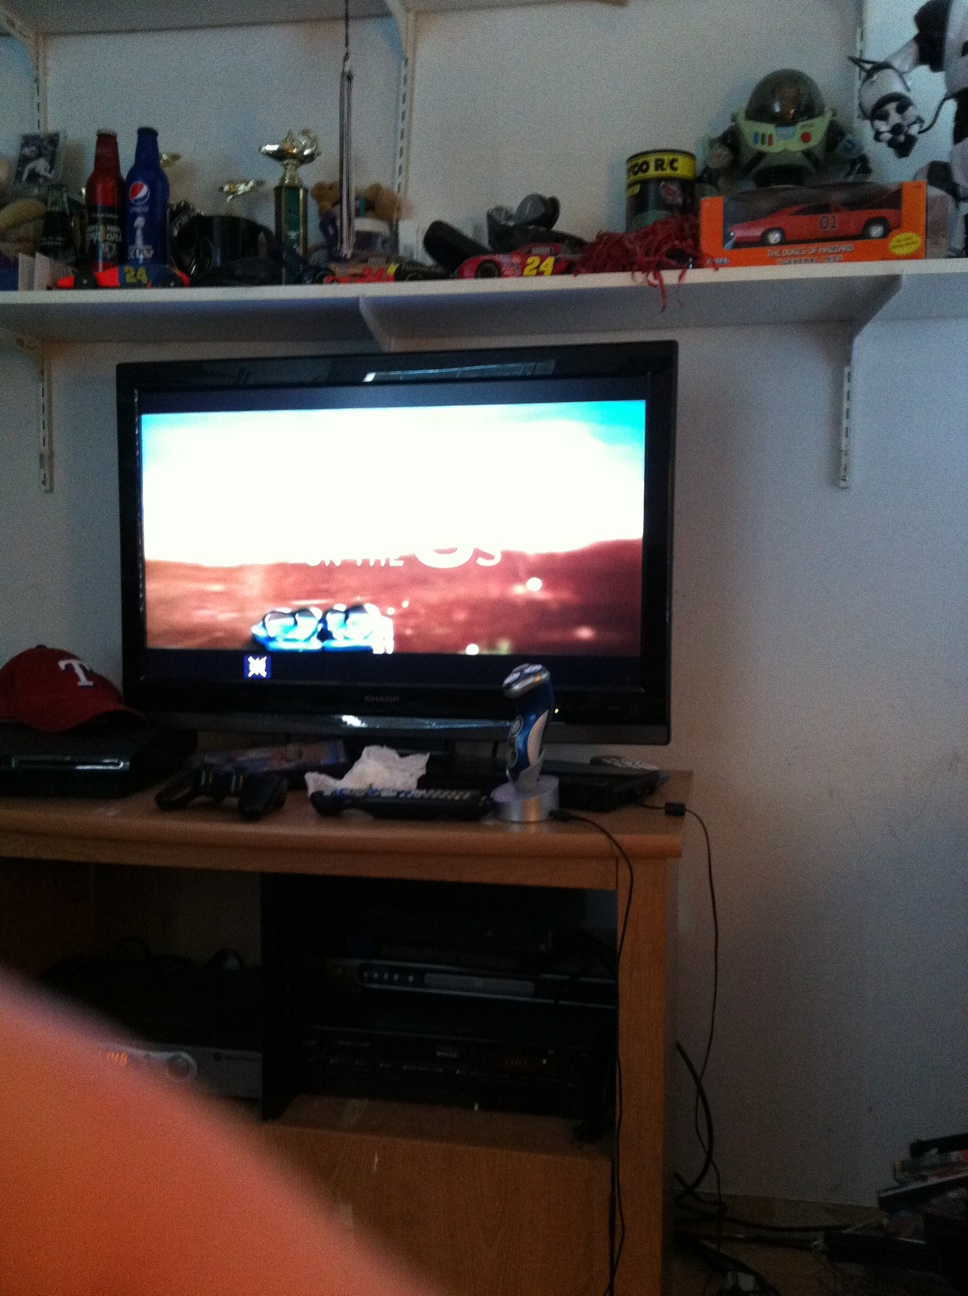Is my TV on? Yes, your TV is on. It appears to be displaying content clearly, indicating that it is powered and functioning. 